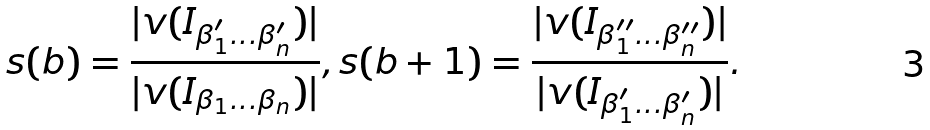<formula> <loc_0><loc_0><loc_500><loc_500>s ( b ) = \frac { | v ( I _ { \beta _ { 1 } ^ { \prime } \dots \beta _ { n } ^ { \prime } } ) | } { | v ( I _ { \beta _ { 1 } \dots \beta _ { n } } ) | } , s ( b + 1 ) = \frac { | v ( I _ { \beta _ { 1 } ^ { \prime \prime } \dots \beta _ { n } ^ { \prime \prime } } ) | } { | v ( I _ { \beta _ { 1 } ^ { \prime } \dots \beta _ { n } ^ { \prime } } ) | } .</formula> 